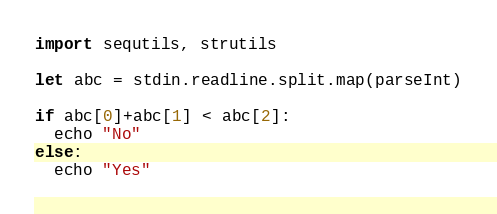<code> <loc_0><loc_0><loc_500><loc_500><_Nim_>import sequtils, strutils

let abc = stdin.readline.split.map(parseInt)

if abc[0]+abc[1] < abc[2]:
  echo "No"
else:
  echo "Yes"
</code> 